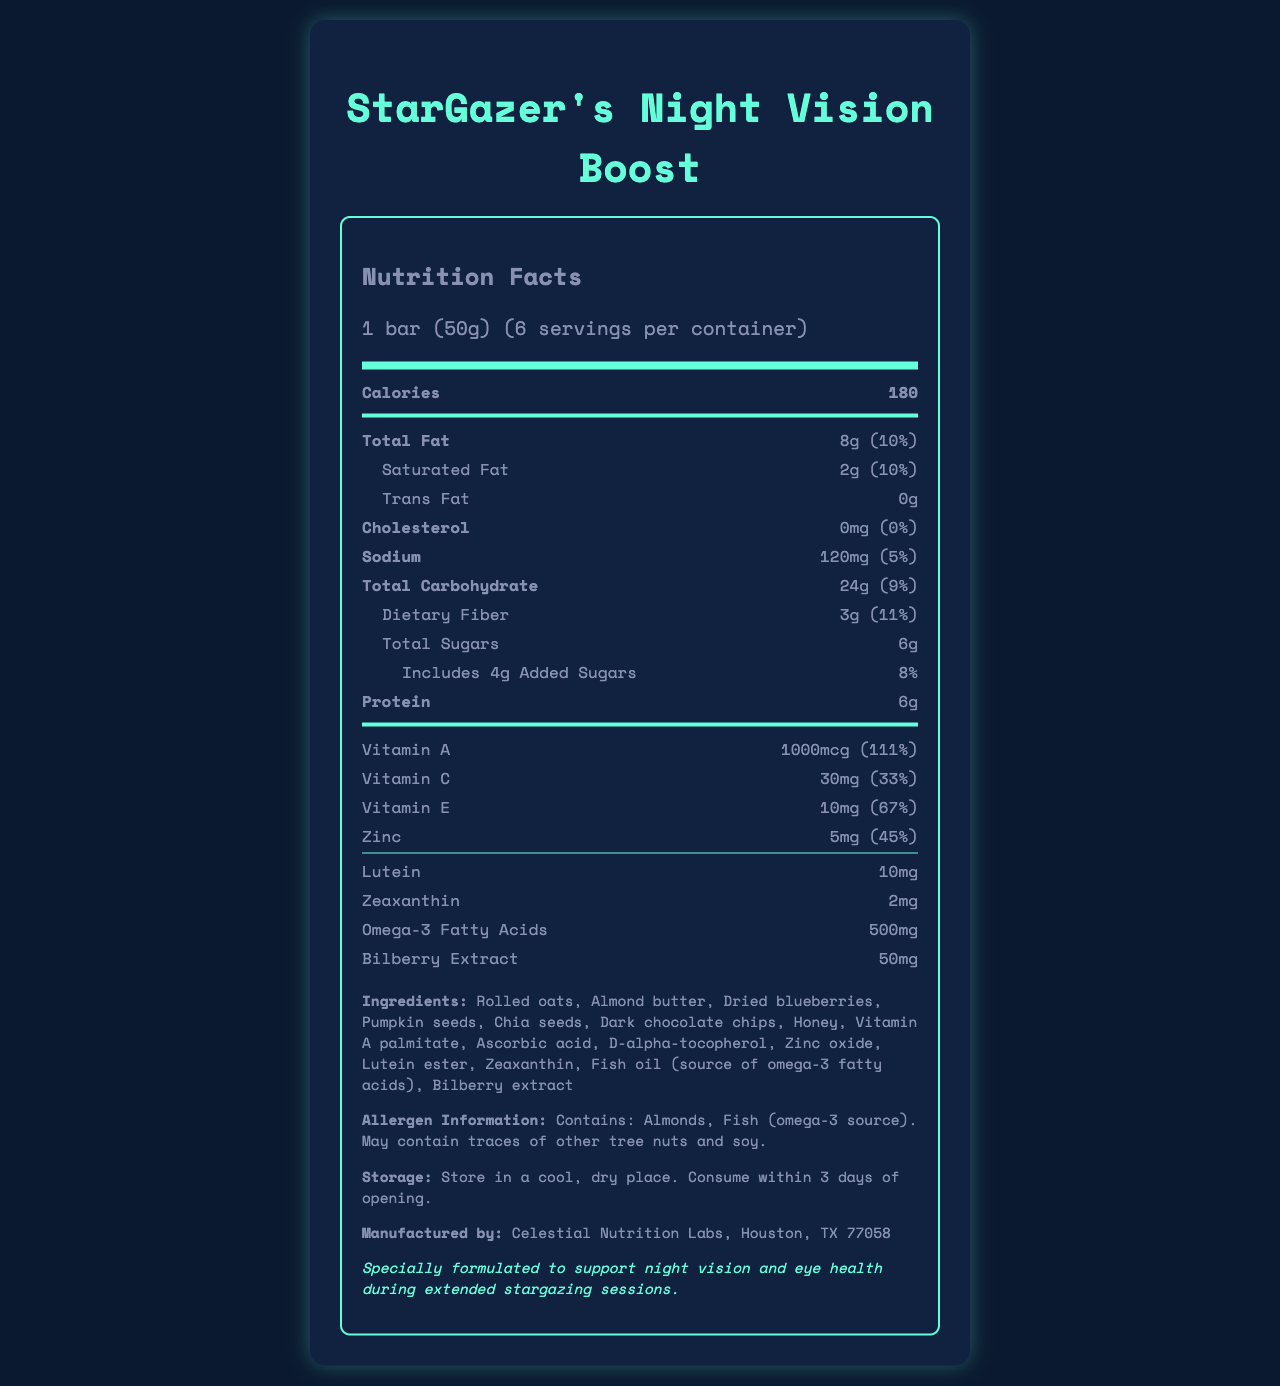what is the serving size of the "StarGazer's Night Vision Boost"? The serving size is indicated as "1 bar (50g)" in the document under the "Nutrition Facts" heading.
Answer: 1 bar (50g) how many servings are there in one container? The document states there are 6 servings per container just below the heading "Nutrition Facts."
Answer: 6 how many calories are in one serving? The document lists 180 calories per serving under the "Calories" section.
Answer: 180 how much saturated fat is in one serving? The document specifies that each serving contains 2g of saturated fat.
Answer: 2g what is the daily value percentage for dietary fiber per serving? The daily value percentage for dietary fiber per serving is listed as 11% in the document.
Answer: 11% which ingredient is the source of omega-3 fatty acids? A. Almond butter B. Fish oil C. Chia seeds D. Pumpkin seeds According to the ingredients list, fish oil is the source of omega-3 fatty acids.
Answer: B how much vitamin A is there in one serving? A. 500mcg B. 800mcg C. 1000mcg D. 3000mcg The amount of vitamin A in one serving is specified as 1000mcg.
Answer: C is there any trans fat in this product? The document indicates that the product contains 0g of trans fat.
Answer: No summarize the main idea of the document. The document is a detailed nutrition label for the product, listing its nutritional contents, ingredients, allergen warnings, storage instructions, and manufactures information, with an emphasis on its benefit for night vision.
Answer: The document provides the nutrition facts for "StarGazer's Night Vision Boost," a snack formulated to enhance night vision for stargazing. It includes details on serving size, calories, and daily value percentages of various nutrients. The ingredients, allergen information, storage instructions, manufacturer information, and health claims are also listed. what is the storage recommendation for this product? Storage instructions recommend keeping the product in a cool, dry place and consuming it within 3 days of opening.
Answer: Store in a cool, dry place. Consume within 3 days of opening. how many grams of protein are there in one serving? The document indicates that one serving contains 6g of protein.
Answer: 6g which vitamins have daily value percentages listed? The daily value percentages are listed for Vitamin A (111%), Vitamin C (33%), and Vitamin E (67%).
Answer: Vitamin A, Vitamin C, and Vitamin E which of the following ingredients are included in the product? A. Rolled oats B. Wheat flour C. Almond butter D. Dried blueberries The ingredients list includes Rolled oats, Almond butter, and Dried blueberries, but not Wheat flour.
Answer: A, C, D what is the manufacturer's name and location? The document indicates that the manufacturer is Celestial Nutrition Labs based in Houston, TX.
Answer: Celestial Nutrition Labs, Houston, TX 77058 how much zinc is in one serving of the product? The zinc content per serving is listed as 5mg in the document.
Answer: 5mg why is the product claimed to be beneficial for stargazers? The document claims that the product is formulated to support night vision and eye health.
Answer: It is specially formulated to support night vision and eye health during extended stargazing sessions. Does the product contain any fish? The document mentions fish (omega-3 source) in the allergen information and ingredients list.
Answer: Yes what is the daily value percentage of sodium per serving? The daily value percentage of sodium per serving is stated as 5% in the document.
Answer: 5% how long can the product be stored after opening? The storage information specifies consuming the product within 3 days of opening.
Answer: 3 days what color is the background of the document? The background color of the document cannot be determined based on the provided document information.
Answer: I don't know 